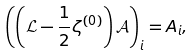<formula> <loc_0><loc_0><loc_500><loc_500>\left ( \left ( \mathcal { L } - \frac { 1 } { 2 } \zeta ^ { ( 0 ) } \right ) \mathcal { A } \right ) _ { i } = A _ { i } ,</formula> 